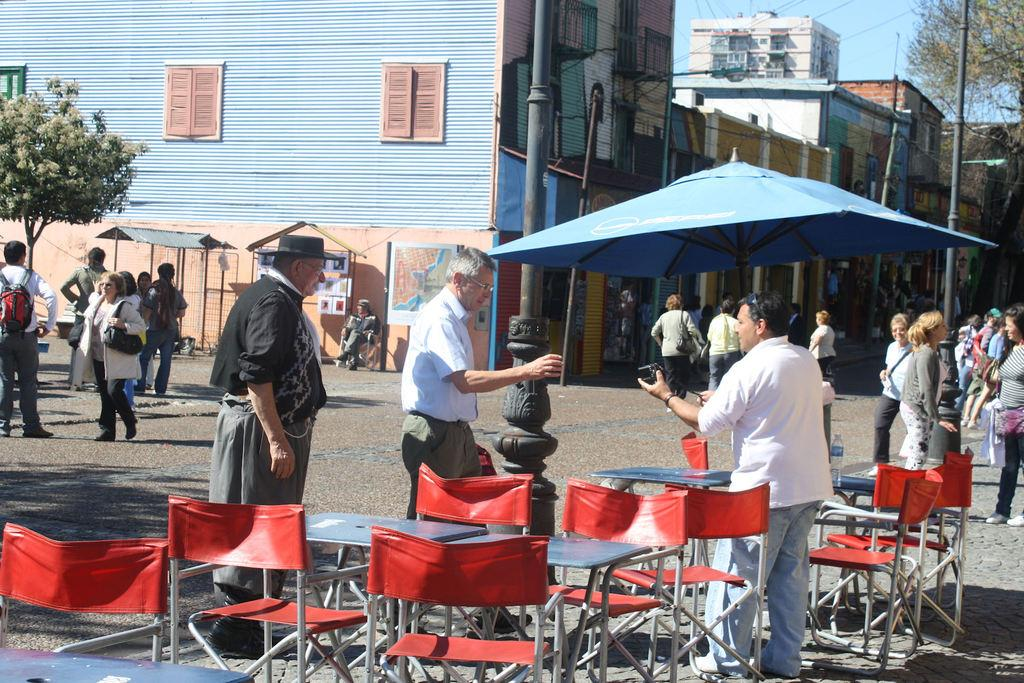What are the people in the image doing? The multiple persons standing on the road suggest they might be waiting or gathering. What objects are present in the image besides the people? There are chairs present in the image. What can be seen in the background of the image? There is a building and a tree in the background. How would you describe the weather in the image? The background appears sunny, suggesting a clear and bright day. Can you see a zephyr blowing through the scene in the image? There is no mention of a zephyr or any wind in the image, so we cannot see one. Are there any goats present in the image? There is no mention of goats or any animals in the image, so we cannot see any. 